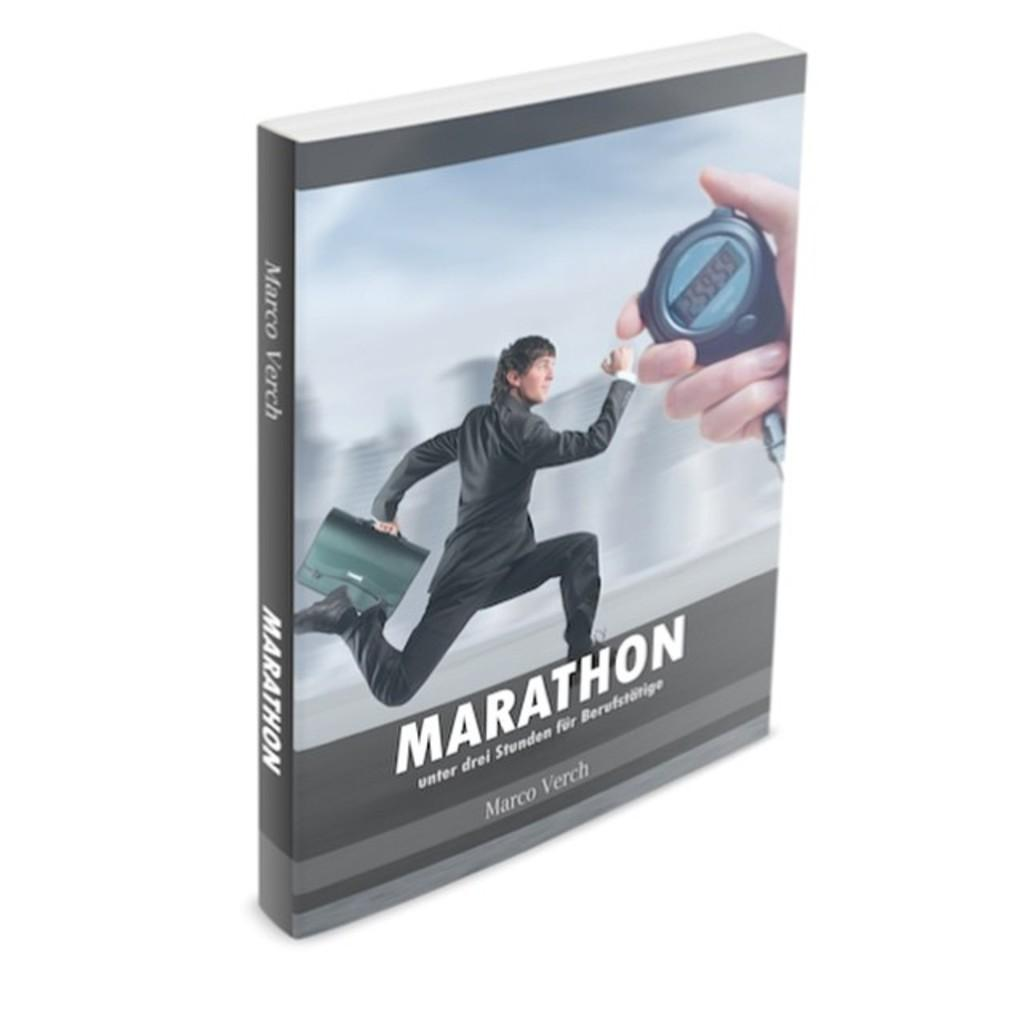<image>
Write a terse but informative summary of the picture. A book called Marathon shows a man running holding a briefcase. 